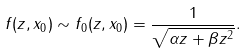<formula> <loc_0><loc_0><loc_500><loc_500>f ( z , x _ { 0 } ) \sim f _ { 0 } ( z , x _ { 0 } ) = \frac { 1 } { \sqrt { \alpha z + \beta z ^ { 2 } } } .</formula> 